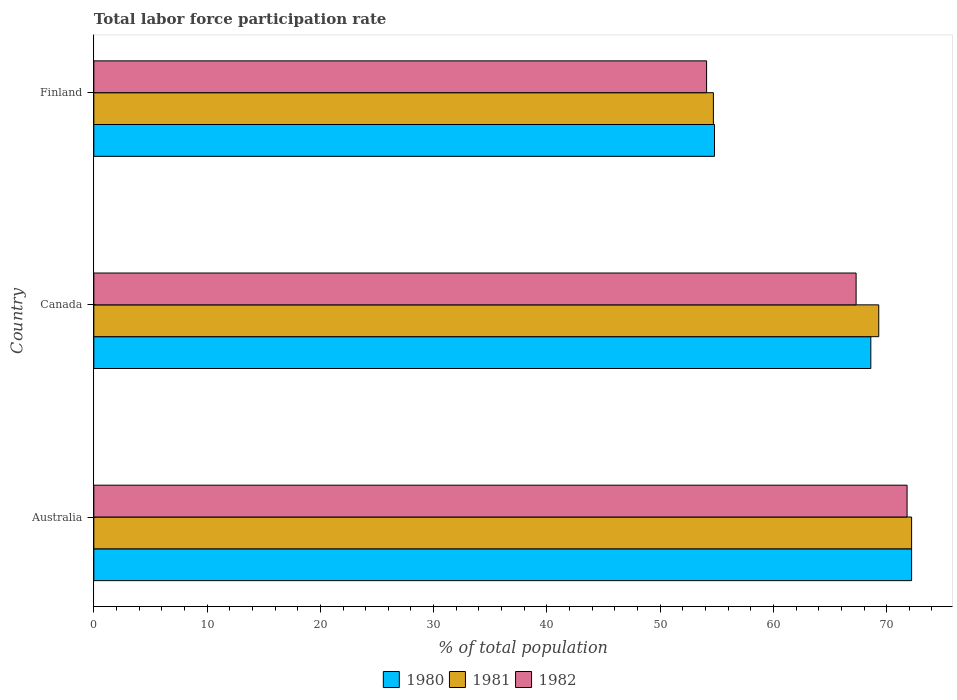How many different coloured bars are there?
Ensure brevity in your answer.  3. How many groups of bars are there?
Make the answer very short. 3. Are the number of bars per tick equal to the number of legend labels?
Your answer should be very brief. Yes. Are the number of bars on each tick of the Y-axis equal?
Provide a succinct answer. Yes. How many bars are there on the 2nd tick from the bottom?
Your answer should be compact. 3. What is the label of the 1st group of bars from the top?
Ensure brevity in your answer.  Finland. What is the total labor force participation rate in 1982 in Canada?
Give a very brief answer. 67.3. Across all countries, what is the maximum total labor force participation rate in 1982?
Provide a succinct answer. 71.8. Across all countries, what is the minimum total labor force participation rate in 1980?
Your response must be concise. 54.8. In which country was the total labor force participation rate in 1980 maximum?
Your answer should be compact. Australia. In which country was the total labor force participation rate in 1982 minimum?
Your response must be concise. Finland. What is the total total labor force participation rate in 1982 in the graph?
Offer a terse response. 193.2. What is the difference between the total labor force participation rate in 1982 in Australia and that in Finland?
Provide a short and direct response. 17.7. What is the difference between the total labor force participation rate in 1980 in Canada and the total labor force participation rate in 1982 in Australia?
Provide a short and direct response. -3.2. What is the average total labor force participation rate in 1980 per country?
Provide a short and direct response. 65.2. What is the difference between the total labor force participation rate in 1982 and total labor force participation rate in 1981 in Finland?
Provide a short and direct response. -0.6. What is the ratio of the total labor force participation rate in 1982 in Canada to that in Finland?
Ensure brevity in your answer.  1.24. Is the difference between the total labor force participation rate in 1982 in Canada and Finland greater than the difference between the total labor force participation rate in 1981 in Canada and Finland?
Offer a terse response. No. What is the difference between the highest and the second highest total labor force participation rate in 1981?
Your answer should be compact. 2.9. What is the difference between the highest and the lowest total labor force participation rate in 1980?
Your answer should be compact. 17.4. Is it the case that in every country, the sum of the total labor force participation rate in 1981 and total labor force participation rate in 1980 is greater than the total labor force participation rate in 1982?
Offer a very short reply. Yes. Are all the bars in the graph horizontal?
Keep it short and to the point. Yes. How many countries are there in the graph?
Make the answer very short. 3. What is the difference between two consecutive major ticks on the X-axis?
Provide a short and direct response. 10. Are the values on the major ticks of X-axis written in scientific E-notation?
Provide a succinct answer. No. Does the graph contain any zero values?
Keep it short and to the point. No. Does the graph contain grids?
Your answer should be very brief. No. Where does the legend appear in the graph?
Give a very brief answer. Bottom center. What is the title of the graph?
Provide a succinct answer. Total labor force participation rate. What is the label or title of the X-axis?
Your answer should be very brief. % of total population. What is the label or title of the Y-axis?
Your response must be concise. Country. What is the % of total population in 1980 in Australia?
Offer a very short reply. 72.2. What is the % of total population of 1981 in Australia?
Make the answer very short. 72.2. What is the % of total population of 1982 in Australia?
Provide a short and direct response. 71.8. What is the % of total population of 1980 in Canada?
Ensure brevity in your answer.  68.6. What is the % of total population of 1981 in Canada?
Your response must be concise. 69.3. What is the % of total population of 1982 in Canada?
Keep it short and to the point. 67.3. What is the % of total population of 1980 in Finland?
Give a very brief answer. 54.8. What is the % of total population of 1981 in Finland?
Offer a terse response. 54.7. What is the % of total population in 1982 in Finland?
Your response must be concise. 54.1. Across all countries, what is the maximum % of total population of 1980?
Your response must be concise. 72.2. Across all countries, what is the maximum % of total population in 1981?
Your response must be concise. 72.2. Across all countries, what is the maximum % of total population of 1982?
Give a very brief answer. 71.8. Across all countries, what is the minimum % of total population in 1980?
Provide a short and direct response. 54.8. Across all countries, what is the minimum % of total population of 1981?
Provide a short and direct response. 54.7. Across all countries, what is the minimum % of total population of 1982?
Provide a short and direct response. 54.1. What is the total % of total population in 1980 in the graph?
Provide a short and direct response. 195.6. What is the total % of total population in 1981 in the graph?
Provide a succinct answer. 196.2. What is the total % of total population of 1982 in the graph?
Your response must be concise. 193.2. What is the difference between the % of total population of 1981 in Australia and that in Canada?
Provide a succinct answer. 2.9. What is the difference between the % of total population in 1982 in Australia and that in Canada?
Provide a short and direct response. 4.5. What is the difference between the % of total population in 1980 in Australia and that in Finland?
Make the answer very short. 17.4. What is the difference between the % of total population of 1982 in Australia and that in Finland?
Provide a short and direct response. 17.7. What is the difference between the % of total population of 1980 in Australia and the % of total population of 1981 in Canada?
Ensure brevity in your answer.  2.9. What is the difference between the % of total population in 1980 in Australia and the % of total population in 1982 in Canada?
Give a very brief answer. 4.9. What is the difference between the % of total population in 1981 in Australia and the % of total population in 1982 in Canada?
Your answer should be very brief. 4.9. What is the difference between the % of total population in 1980 in Canada and the % of total population in 1981 in Finland?
Make the answer very short. 13.9. What is the difference between the % of total population in 1980 in Canada and the % of total population in 1982 in Finland?
Keep it short and to the point. 14.5. What is the average % of total population in 1980 per country?
Give a very brief answer. 65.2. What is the average % of total population in 1981 per country?
Offer a terse response. 65.4. What is the average % of total population of 1982 per country?
Make the answer very short. 64.4. What is the difference between the % of total population in 1980 and % of total population in 1981 in Australia?
Your answer should be very brief. 0. What is the difference between the % of total population in 1980 and % of total population in 1982 in Australia?
Provide a succinct answer. 0.4. What is the difference between the % of total population of 1981 and % of total population of 1982 in Canada?
Offer a very short reply. 2. What is the difference between the % of total population of 1980 and % of total population of 1982 in Finland?
Make the answer very short. 0.7. What is the ratio of the % of total population of 1980 in Australia to that in Canada?
Offer a very short reply. 1.05. What is the ratio of the % of total population in 1981 in Australia to that in Canada?
Provide a short and direct response. 1.04. What is the ratio of the % of total population of 1982 in Australia to that in Canada?
Provide a short and direct response. 1.07. What is the ratio of the % of total population of 1980 in Australia to that in Finland?
Provide a succinct answer. 1.32. What is the ratio of the % of total population in 1981 in Australia to that in Finland?
Ensure brevity in your answer.  1.32. What is the ratio of the % of total population in 1982 in Australia to that in Finland?
Offer a very short reply. 1.33. What is the ratio of the % of total population in 1980 in Canada to that in Finland?
Provide a short and direct response. 1.25. What is the ratio of the % of total population in 1981 in Canada to that in Finland?
Keep it short and to the point. 1.27. What is the ratio of the % of total population in 1982 in Canada to that in Finland?
Provide a succinct answer. 1.24. What is the difference between the highest and the second highest % of total population of 1980?
Provide a short and direct response. 3.6. What is the difference between the highest and the lowest % of total population in 1980?
Keep it short and to the point. 17.4. What is the difference between the highest and the lowest % of total population of 1981?
Your answer should be very brief. 17.5. 